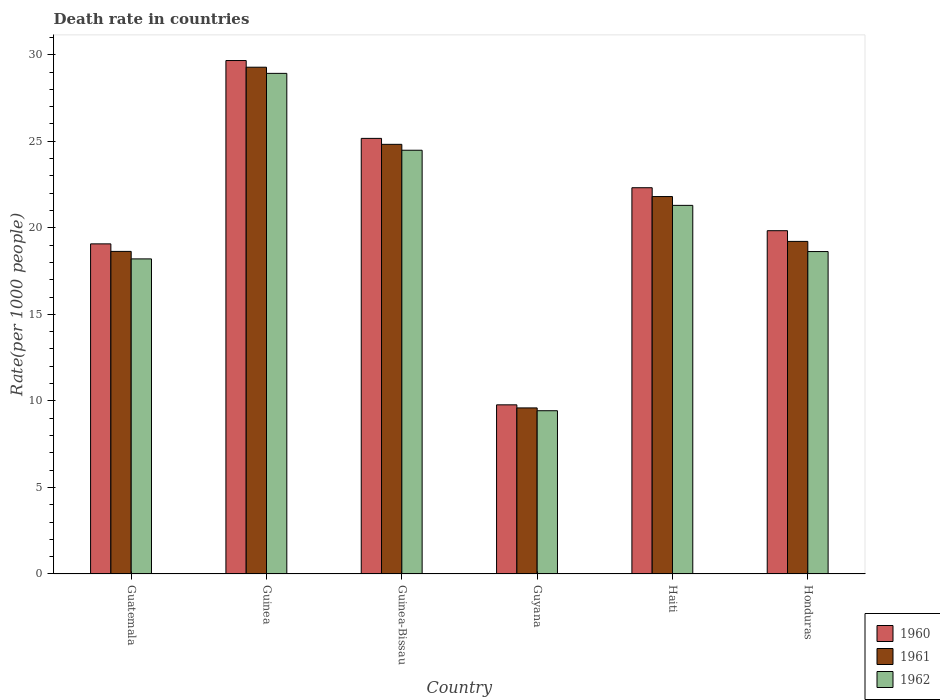Are the number of bars per tick equal to the number of legend labels?
Your answer should be compact. Yes. Are the number of bars on each tick of the X-axis equal?
Keep it short and to the point. Yes. How many bars are there on the 3rd tick from the left?
Make the answer very short. 3. How many bars are there on the 2nd tick from the right?
Make the answer very short. 3. What is the label of the 5th group of bars from the left?
Offer a terse response. Haiti. In how many cases, is the number of bars for a given country not equal to the number of legend labels?
Offer a very short reply. 0. What is the death rate in 1961 in Guatemala?
Offer a very short reply. 18.64. Across all countries, what is the maximum death rate in 1962?
Make the answer very short. 28.92. Across all countries, what is the minimum death rate in 1961?
Provide a short and direct response. 9.6. In which country was the death rate in 1962 maximum?
Your response must be concise. Guinea. In which country was the death rate in 1960 minimum?
Provide a succinct answer. Guyana. What is the total death rate in 1962 in the graph?
Provide a succinct answer. 120.97. What is the difference between the death rate in 1960 in Haiti and that in Honduras?
Offer a terse response. 2.48. What is the difference between the death rate in 1960 in Haiti and the death rate in 1961 in Guinea?
Your response must be concise. -6.96. What is the average death rate in 1962 per country?
Provide a short and direct response. 20.16. What is the difference between the death rate of/in 1962 and death rate of/in 1961 in Honduras?
Your answer should be compact. -0.59. What is the ratio of the death rate in 1960 in Guyana to that in Honduras?
Your answer should be compact. 0.49. Is the death rate in 1960 in Guinea-Bissau less than that in Haiti?
Provide a short and direct response. No. Is the difference between the death rate in 1962 in Guatemala and Haiti greater than the difference between the death rate in 1961 in Guatemala and Haiti?
Keep it short and to the point. Yes. What is the difference between the highest and the second highest death rate in 1961?
Give a very brief answer. 3.02. What is the difference between the highest and the lowest death rate in 1962?
Ensure brevity in your answer.  19.49. Is the sum of the death rate in 1962 in Guinea and Haiti greater than the maximum death rate in 1960 across all countries?
Ensure brevity in your answer.  Yes. What does the 1st bar from the left in Honduras represents?
Give a very brief answer. 1960. Is it the case that in every country, the sum of the death rate in 1961 and death rate in 1962 is greater than the death rate in 1960?
Your response must be concise. Yes. Are all the bars in the graph horizontal?
Your response must be concise. No. Are the values on the major ticks of Y-axis written in scientific E-notation?
Make the answer very short. No. Does the graph contain any zero values?
Ensure brevity in your answer.  No. Does the graph contain grids?
Offer a very short reply. No. What is the title of the graph?
Provide a succinct answer. Death rate in countries. What is the label or title of the Y-axis?
Make the answer very short. Rate(per 1000 people). What is the Rate(per 1000 people) in 1960 in Guatemala?
Your answer should be compact. 19.07. What is the Rate(per 1000 people) of 1961 in Guatemala?
Your answer should be compact. 18.64. What is the Rate(per 1000 people) in 1962 in Guatemala?
Your answer should be very brief. 18.2. What is the Rate(per 1000 people) in 1960 in Guinea?
Offer a very short reply. 29.66. What is the Rate(per 1000 people) of 1961 in Guinea?
Offer a terse response. 29.28. What is the Rate(per 1000 people) in 1962 in Guinea?
Offer a terse response. 28.92. What is the Rate(per 1000 people) of 1960 in Guinea-Bissau?
Your response must be concise. 25.17. What is the Rate(per 1000 people) in 1961 in Guinea-Bissau?
Ensure brevity in your answer.  24.82. What is the Rate(per 1000 people) in 1962 in Guinea-Bissau?
Ensure brevity in your answer.  24.48. What is the Rate(per 1000 people) of 1960 in Guyana?
Keep it short and to the point. 9.77. What is the Rate(per 1000 people) of 1961 in Guyana?
Provide a succinct answer. 9.6. What is the Rate(per 1000 people) in 1962 in Guyana?
Your answer should be compact. 9.43. What is the Rate(per 1000 people) in 1960 in Haiti?
Keep it short and to the point. 22.32. What is the Rate(per 1000 people) in 1961 in Haiti?
Ensure brevity in your answer.  21.81. What is the Rate(per 1000 people) in 1962 in Haiti?
Keep it short and to the point. 21.3. What is the Rate(per 1000 people) in 1960 in Honduras?
Provide a short and direct response. 19.83. What is the Rate(per 1000 people) in 1961 in Honduras?
Offer a very short reply. 19.22. What is the Rate(per 1000 people) in 1962 in Honduras?
Ensure brevity in your answer.  18.63. Across all countries, what is the maximum Rate(per 1000 people) in 1960?
Give a very brief answer. 29.66. Across all countries, what is the maximum Rate(per 1000 people) of 1961?
Your answer should be compact. 29.28. Across all countries, what is the maximum Rate(per 1000 people) of 1962?
Make the answer very short. 28.92. Across all countries, what is the minimum Rate(per 1000 people) of 1960?
Offer a terse response. 9.77. Across all countries, what is the minimum Rate(per 1000 people) in 1961?
Your response must be concise. 9.6. Across all countries, what is the minimum Rate(per 1000 people) of 1962?
Your answer should be compact. 9.43. What is the total Rate(per 1000 people) of 1960 in the graph?
Keep it short and to the point. 125.83. What is the total Rate(per 1000 people) of 1961 in the graph?
Give a very brief answer. 123.36. What is the total Rate(per 1000 people) of 1962 in the graph?
Offer a terse response. 120.97. What is the difference between the Rate(per 1000 people) in 1960 in Guatemala and that in Guinea?
Offer a very short reply. -10.59. What is the difference between the Rate(per 1000 people) of 1961 in Guatemala and that in Guinea?
Make the answer very short. -10.64. What is the difference between the Rate(per 1000 people) in 1962 in Guatemala and that in Guinea?
Make the answer very short. -10.72. What is the difference between the Rate(per 1000 people) in 1960 in Guatemala and that in Guinea-Bissau?
Your answer should be very brief. -6.09. What is the difference between the Rate(per 1000 people) in 1961 in Guatemala and that in Guinea-Bissau?
Provide a short and direct response. -6.19. What is the difference between the Rate(per 1000 people) in 1962 in Guatemala and that in Guinea-Bissau?
Give a very brief answer. -6.28. What is the difference between the Rate(per 1000 people) of 1961 in Guatemala and that in Guyana?
Your answer should be compact. 9.04. What is the difference between the Rate(per 1000 people) in 1962 in Guatemala and that in Guyana?
Ensure brevity in your answer.  8.77. What is the difference between the Rate(per 1000 people) in 1960 in Guatemala and that in Haiti?
Keep it short and to the point. -3.24. What is the difference between the Rate(per 1000 people) of 1961 in Guatemala and that in Haiti?
Give a very brief answer. -3.17. What is the difference between the Rate(per 1000 people) in 1962 in Guatemala and that in Haiti?
Your response must be concise. -3.09. What is the difference between the Rate(per 1000 people) in 1960 in Guatemala and that in Honduras?
Provide a succinct answer. -0.76. What is the difference between the Rate(per 1000 people) in 1961 in Guatemala and that in Honduras?
Your answer should be very brief. -0.58. What is the difference between the Rate(per 1000 people) of 1962 in Guatemala and that in Honduras?
Your answer should be compact. -0.42. What is the difference between the Rate(per 1000 people) in 1960 in Guinea and that in Guinea-Bissau?
Offer a very short reply. 4.5. What is the difference between the Rate(per 1000 people) in 1961 in Guinea and that in Guinea-Bissau?
Offer a very short reply. 4.46. What is the difference between the Rate(per 1000 people) in 1962 in Guinea and that in Guinea-Bissau?
Your answer should be very brief. 4.44. What is the difference between the Rate(per 1000 people) of 1960 in Guinea and that in Guyana?
Offer a terse response. 19.89. What is the difference between the Rate(per 1000 people) in 1961 in Guinea and that in Guyana?
Offer a very short reply. 19.68. What is the difference between the Rate(per 1000 people) in 1962 in Guinea and that in Guyana?
Make the answer very short. 19.49. What is the difference between the Rate(per 1000 people) in 1960 in Guinea and that in Haiti?
Your answer should be very brief. 7.35. What is the difference between the Rate(per 1000 people) of 1961 in Guinea and that in Haiti?
Offer a very short reply. 7.47. What is the difference between the Rate(per 1000 people) of 1962 in Guinea and that in Haiti?
Make the answer very short. 7.63. What is the difference between the Rate(per 1000 people) in 1960 in Guinea and that in Honduras?
Keep it short and to the point. 9.83. What is the difference between the Rate(per 1000 people) in 1961 in Guinea and that in Honduras?
Offer a very short reply. 10.06. What is the difference between the Rate(per 1000 people) of 1962 in Guinea and that in Honduras?
Keep it short and to the point. 10.29. What is the difference between the Rate(per 1000 people) in 1960 in Guinea-Bissau and that in Guyana?
Your response must be concise. 15.39. What is the difference between the Rate(per 1000 people) of 1961 in Guinea-Bissau and that in Guyana?
Offer a terse response. 15.23. What is the difference between the Rate(per 1000 people) in 1962 in Guinea-Bissau and that in Guyana?
Give a very brief answer. 15.05. What is the difference between the Rate(per 1000 people) in 1960 in Guinea-Bissau and that in Haiti?
Give a very brief answer. 2.85. What is the difference between the Rate(per 1000 people) in 1961 in Guinea-Bissau and that in Haiti?
Make the answer very short. 3.02. What is the difference between the Rate(per 1000 people) in 1962 in Guinea-Bissau and that in Haiti?
Your answer should be very brief. 3.19. What is the difference between the Rate(per 1000 people) of 1960 in Guinea-Bissau and that in Honduras?
Your answer should be very brief. 5.33. What is the difference between the Rate(per 1000 people) in 1961 in Guinea-Bissau and that in Honduras?
Make the answer very short. 5.61. What is the difference between the Rate(per 1000 people) in 1962 in Guinea-Bissau and that in Honduras?
Your response must be concise. 5.85. What is the difference between the Rate(per 1000 people) of 1960 in Guyana and that in Haiti?
Your answer should be very brief. -12.54. What is the difference between the Rate(per 1000 people) of 1961 in Guyana and that in Haiti?
Offer a very short reply. -12.21. What is the difference between the Rate(per 1000 people) in 1962 in Guyana and that in Haiti?
Offer a very short reply. -11.87. What is the difference between the Rate(per 1000 people) in 1960 in Guyana and that in Honduras?
Ensure brevity in your answer.  -10.06. What is the difference between the Rate(per 1000 people) in 1961 in Guyana and that in Honduras?
Your answer should be very brief. -9.62. What is the difference between the Rate(per 1000 people) in 1962 in Guyana and that in Honduras?
Your response must be concise. -9.2. What is the difference between the Rate(per 1000 people) of 1960 in Haiti and that in Honduras?
Provide a short and direct response. 2.48. What is the difference between the Rate(per 1000 people) of 1961 in Haiti and that in Honduras?
Your response must be concise. 2.59. What is the difference between the Rate(per 1000 people) of 1962 in Haiti and that in Honduras?
Ensure brevity in your answer.  2.67. What is the difference between the Rate(per 1000 people) of 1960 in Guatemala and the Rate(per 1000 people) of 1961 in Guinea?
Give a very brief answer. -10.21. What is the difference between the Rate(per 1000 people) of 1960 in Guatemala and the Rate(per 1000 people) of 1962 in Guinea?
Provide a succinct answer. -9.85. What is the difference between the Rate(per 1000 people) in 1961 in Guatemala and the Rate(per 1000 people) in 1962 in Guinea?
Offer a very short reply. -10.29. What is the difference between the Rate(per 1000 people) in 1960 in Guatemala and the Rate(per 1000 people) in 1961 in Guinea-Bissau?
Your response must be concise. -5.75. What is the difference between the Rate(per 1000 people) in 1960 in Guatemala and the Rate(per 1000 people) in 1962 in Guinea-Bissau?
Offer a terse response. -5.41. What is the difference between the Rate(per 1000 people) in 1961 in Guatemala and the Rate(per 1000 people) in 1962 in Guinea-Bissau?
Give a very brief answer. -5.84. What is the difference between the Rate(per 1000 people) of 1960 in Guatemala and the Rate(per 1000 people) of 1961 in Guyana?
Your answer should be compact. 9.48. What is the difference between the Rate(per 1000 people) in 1960 in Guatemala and the Rate(per 1000 people) in 1962 in Guyana?
Provide a short and direct response. 9.64. What is the difference between the Rate(per 1000 people) of 1961 in Guatemala and the Rate(per 1000 people) of 1962 in Guyana?
Provide a short and direct response. 9.21. What is the difference between the Rate(per 1000 people) of 1960 in Guatemala and the Rate(per 1000 people) of 1961 in Haiti?
Your answer should be very brief. -2.73. What is the difference between the Rate(per 1000 people) of 1960 in Guatemala and the Rate(per 1000 people) of 1962 in Haiti?
Offer a very short reply. -2.23. What is the difference between the Rate(per 1000 people) of 1961 in Guatemala and the Rate(per 1000 people) of 1962 in Haiti?
Offer a terse response. -2.66. What is the difference between the Rate(per 1000 people) in 1960 in Guatemala and the Rate(per 1000 people) in 1961 in Honduras?
Provide a succinct answer. -0.14. What is the difference between the Rate(per 1000 people) of 1960 in Guatemala and the Rate(per 1000 people) of 1962 in Honduras?
Provide a short and direct response. 0.44. What is the difference between the Rate(per 1000 people) in 1961 in Guatemala and the Rate(per 1000 people) in 1962 in Honduras?
Your answer should be very brief. 0.01. What is the difference between the Rate(per 1000 people) in 1960 in Guinea and the Rate(per 1000 people) in 1961 in Guinea-Bissau?
Give a very brief answer. 4.84. What is the difference between the Rate(per 1000 people) of 1960 in Guinea and the Rate(per 1000 people) of 1962 in Guinea-Bissau?
Provide a short and direct response. 5.18. What is the difference between the Rate(per 1000 people) of 1961 in Guinea and the Rate(per 1000 people) of 1962 in Guinea-Bissau?
Your answer should be compact. 4.8. What is the difference between the Rate(per 1000 people) in 1960 in Guinea and the Rate(per 1000 people) in 1961 in Guyana?
Your response must be concise. 20.07. What is the difference between the Rate(per 1000 people) of 1960 in Guinea and the Rate(per 1000 people) of 1962 in Guyana?
Provide a succinct answer. 20.23. What is the difference between the Rate(per 1000 people) of 1961 in Guinea and the Rate(per 1000 people) of 1962 in Guyana?
Ensure brevity in your answer.  19.85. What is the difference between the Rate(per 1000 people) of 1960 in Guinea and the Rate(per 1000 people) of 1961 in Haiti?
Your answer should be very brief. 7.86. What is the difference between the Rate(per 1000 people) of 1960 in Guinea and the Rate(per 1000 people) of 1962 in Haiti?
Make the answer very short. 8.37. What is the difference between the Rate(per 1000 people) in 1961 in Guinea and the Rate(per 1000 people) in 1962 in Haiti?
Your answer should be compact. 7.98. What is the difference between the Rate(per 1000 people) in 1960 in Guinea and the Rate(per 1000 people) in 1961 in Honduras?
Offer a terse response. 10.45. What is the difference between the Rate(per 1000 people) in 1960 in Guinea and the Rate(per 1000 people) in 1962 in Honduras?
Your response must be concise. 11.04. What is the difference between the Rate(per 1000 people) of 1961 in Guinea and the Rate(per 1000 people) of 1962 in Honduras?
Provide a short and direct response. 10.65. What is the difference between the Rate(per 1000 people) in 1960 in Guinea-Bissau and the Rate(per 1000 people) in 1961 in Guyana?
Give a very brief answer. 15.57. What is the difference between the Rate(per 1000 people) of 1960 in Guinea-Bissau and the Rate(per 1000 people) of 1962 in Guyana?
Your response must be concise. 15.74. What is the difference between the Rate(per 1000 people) in 1961 in Guinea-Bissau and the Rate(per 1000 people) in 1962 in Guyana?
Your response must be concise. 15.39. What is the difference between the Rate(per 1000 people) in 1960 in Guinea-Bissau and the Rate(per 1000 people) in 1961 in Haiti?
Offer a terse response. 3.36. What is the difference between the Rate(per 1000 people) of 1960 in Guinea-Bissau and the Rate(per 1000 people) of 1962 in Haiti?
Provide a short and direct response. 3.87. What is the difference between the Rate(per 1000 people) of 1961 in Guinea-Bissau and the Rate(per 1000 people) of 1962 in Haiti?
Ensure brevity in your answer.  3.53. What is the difference between the Rate(per 1000 people) of 1960 in Guinea-Bissau and the Rate(per 1000 people) of 1961 in Honduras?
Your answer should be compact. 5.95. What is the difference between the Rate(per 1000 people) in 1960 in Guinea-Bissau and the Rate(per 1000 people) in 1962 in Honduras?
Ensure brevity in your answer.  6.54. What is the difference between the Rate(per 1000 people) in 1961 in Guinea-Bissau and the Rate(per 1000 people) in 1962 in Honduras?
Keep it short and to the point. 6.2. What is the difference between the Rate(per 1000 people) of 1960 in Guyana and the Rate(per 1000 people) of 1961 in Haiti?
Your response must be concise. -12.03. What is the difference between the Rate(per 1000 people) of 1960 in Guyana and the Rate(per 1000 people) of 1962 in Haiti?
Offer a very short reply. -11.53. What is the difference between the Rate(per 1000 people) of 1961 in Guyana and the Rate(per 1000 people) of 1962 in Haiti?
Offer a terse response. -11.7. What is the difference between the Rate(per 1000 people) of 1960 in Guyana and the Rate(per 1000 people) of 1961 in Honduras?
Your response must be concise. -9.44. What is the difference between the Rate(per 1000 people) in 1960 in Guyana and the Rate(per 1000 people) in 1962 in Honduras?
Ensure brevity in your answer.  -8.86. What is the difference between the Rate(per 1000 people) in 1961 in Guyana and the Rate(per 1000 people) in 1962 in Honduras?
Provide a succinct answer. -9.03. What is the difference between the Rate(per 1000 people) of 1960 in Haiti and the Rate(per 1000 people) of 1961 in Honduras?
Offer a terse response. 3.1. What is the difference between the Rate(per 1000 people) of 1960 in Haiti and the Rate(per 1000 people) of 1962 in Honduras?
Your answer should be very brief. 3.69. What is the difference between the Rate(per 1000 people) in 1961 in Haiti and the Rate(per 1000 people) in 1962 in Honduras?
Your response must be concise. 3.18. What is the average Rate(per 1000 people) in 1960 per country?
Your response must be concise. 20.97. What is the average Rate(per 1000 people) in 1961 per country?
Keep it short and to the point. 20.56. What is the average Rate(per 1000 people) of 1962 per country?
Provide a short and direct response. 20.16. What is the difference between the Rate(per 1000 people) of 1960 and Rate(per 1000 people) of 1961 in Guatemala?
Your answer should be very brief. 0.43. What is the difference between the Rate(per 1000 people) of 1960 and Rate(per 1000 people) of 1962 in Guatemala?
Your answer should be very brief. 0.87. What is the difference between the Rate(per 1000 people) of 1961 and Rate(per 1000 people) of 1962 in Guatemala?
Keep it short and to the point. 0.43. What is the difference between the Rate(per 1000 people) of 1960 and Rate(per 1000 people) of 1961 in Guinea?
Keep it short and to the point. 0.39. What is the difference between the Rate(per 1000 people) of 1960 and Rate(per 1000 people) of 1962 in Guinea?
Your answer should be very brief. 0.74. What is the difference between the Rate(per 1000 people) of 1961 and Rate(per 1000 people) of 1962 in Guinea?
Your answer should be compact. 0.36. What is the difference between the Rate(per 1000 people) in 1960 and Rate(per 1000 people) in 1961 in Guinea-Bissau?
Your answer should be compact. 0.34. What is the difference between the Rate(per 1000 people) in 1960 and Rate(per 1000 people) in 1962 in Guinea-Bissau?
Your answer should be very brief. 0.69. What is the difference between the Rate(per 1000 people) of 1961 and Rate(per 1000 people) of 1962 in Guinea-Bissau?
Make the answer very short. 0.34. What is the difference between the Rate(per 1000 people) in 1960 and Rate(per 1000 people) in 1961 in Guyana?
Your answer should be very brief. 0.18. What is the difference between the Rate(per 1000 people) of 1960 and Rate(per 1000 people) of 1962 in Guyana?
Give a very brief answer. 0.34. What is the difference between the Rate(per 1000 people) in 1961 and Rate(per 1000 people) in 1962 in Guyana?
Offer a very short reply. 0.16. What is the difference between the Rate(per 1000 people) of 1960 and Rate(per 1000 people) of 1961 in Haiti?
Provide a succinct answer. 0.51. What is the difference between the Rate(per 1000 people) of 1960 and Rate(per 1000 people) of 1962 in Haiti?
Ensure brevity in your answer.  1.02. What is the difference between the Rate(per 1000 people) of 1961 and Rate(per 1000 people) of 1962 in Haiti?
Your answer should be compact. 0.51. What is the difference between the Rate(per 1000 people) of 1960 and Rate(per 1000 people) of 1961 in Honduras?
Give a very brief answer. 0.62. What is the difference between the Rate(per 1000 people) of 1960 and Rate(per 1000 people) of 1962 in Honduras?
Your answer should be very brief. 1.21. What is the difference between the Rate(per 1000 people) of 1961 and Rate(per 1000 people) of 1962 in Honduras?
Your answer should be very brief. 0.59. What is the ratio of the Rate(per 1000 people) of 1960 in Guatemala to that in Guinea?
Offer a very short reply. 0.64. What is the ratio of the Rate(per 1000 people) of 1961 in Guatemala to that in Guinea?
Offer a very short reply. 0.64. What is the ratio of the Rate(per 1000 people) in 1962 in Guatemala to that in Guinea?
Offer a very short reply. 0.63. What is the ratio of the Rate(per 1000 people) of 1960 in Guatemala to that in Guinea-Bissau?
Provide a short and direct response. 0.76. What is the ratio of the Rate(per 1000 people) of 1961 in Guatemala to that in Guinea-Bissau?
Provide a succinct answer. 0.75. What is the ratio of the Rate(per 1000 people) in 1962 in Guatemala to that in Guinea-Bissau?
Offer a very short reply. 0.74. What is the ratio of the Rate(per 1000 people) in 1960 in Guatemala to that in Guyana?
Provide a short and direct response. 1.95. What is the ratio of the Rate(per 1000 people) of 1961 in Guatemala to that in Guyana?
Keep it short and to the point. 1.94. What is the ratio of the Rate(per 1000 people) in 1962 in Guatemala to that in Guyana?
Provide a short and direct response. 1.93. What is the ratio of the Rate(per 1000 people) in 1960 in Guatemala to that in Haiti?
Your answer should be very brief. 0.85. What is the ratio of the Rate(per 1000 people) of 1961 in Guatemala to that in Haiti?
Your answer should be very brief. 0.85. What is the ratio of the Rate(per 1000 people) in 1962 in Guatemala to that in Haiti?
Offer a very short reply. 0.85. What is the ratio of the Rate(per 1000 people) of 1960 in Guatemala to that in Honduras?
Provide a short and direct response. 0.96. What is the ratio of the Rate(per 1000 people) in 1961 in Guatemala to that in Honduras?
Offer a very short reply. 0.97. What is the ratio of the Rate(per 1000 people) in 1962 in Guatemala to that in Honduras?
Keep it short and to the point. 0.98. What is the ratio of the Rate(per 1000 people) of 1960 in Guinea to that in Guinea-Bissau?
Offer a very short reply. 1.18. What is the ratio of the Rate(per 1000 people) in 1961 in Guinea to that in Guinea-Bissau?
Make the answer very short. 1.18. What is the ratio of the Rate(per 1000 people) in 1962 in Guinea to that in Guinea-Bissau?
Make the answer very short. 1.18. What is the ratio of the Rate(per 1000 people) of 1960 in Guinea to that in Guyana?
Your response must be concise. 3.04. What is the ratio of the Rate(per 1000 people) in 1961 in Guinea to that in Guyana?
Your response must be concise. 3.05. What is the ratio of the Rate(per 1000 people) in 1962 in Guinea to that in Guyana?
Provide a short and direct response. 3.07. What is the ratio of the Rate(per 1000 people) of 1960 in Guinea to that in Haiti?
Ensure brevity in your answer.  1.33. What is the ratio of the Rate(per 1000 people) in 1961 in Guinea to that in Haiti?
Provide a succinct answer. 1.34. What is the ratio of the Rate(per 1000 people) of 1962 in Guinea to that in Haiti?
Provide a succinct answer. 1.36. What is the ratio of the Rate(per 1000 people) in 1960 in Guinea to that in Honduras?
Offer a very short reply. 1.5. What is the ratio of the Rate(per 1000 people) in 1961 in Guinea to that in Honduras?
Your answer should be compact. 1.52. What is the ratio of the Rate(per 1000 people) of 1962 in Guinea to that in Honduras?
Offer a very short reply. 1.55. What is the ratio of the Rate(per 1000 people) in 1960 in Guinea-Bissau to that in Guyana?
Give a very brief answer. 2.58. What is the ratio of the Rate(per 1000 people) of 1961 in Guinea-Bissau to that in Guyana?
Your answer should be compact. 2.59. What is the ratio of the Rate(per 1000 people) of 1962 in Guinea-Bissau to that in Guyana?
Your answer should be compact. 2.6. What is the ratio of the Rate(per 1000 people) of 1960 in Guinea-Bissau to that in Haiti?
Give a very brief answer. 1.13. What is the ratio of the Rate(per 1000 people) in 1961 in Guinea-Bissau to that in Haiti?
Your answer should be compact. 1.14. What is the ratio of the Rate(per 1000 people) in 1962 in Guinea-Bissau to that in Haiti?
Ensure brevity in your answer.  1.15. What is the ratio of the Rate(per 1000 people) of 1960 in Guinea-Bissau to that in Honduras?
Your answer should be compact. 1.27. What is the ratio of the Rate(per 1000 people) in 1961 in Guinea-Bissau to that in Honduras?
Your response must be concise. 1.29. What is the ratio of the Rate(per 1000 people) in 1962 in Guinea-Bissau to that in Honduras?
Give a very brief answer. 1.31. What is the ratio of the Rate(per 1000 people) of 1960 in Guyana to that in Haiti?
Give a very brief answer. 0.44. What is the ratio of the Rate(per 1000 people) in 1961 in Guyana to that in Haiti?
Your response must be concise. 0.44. What is the ratio of the Rate(per 1000 people) of 1962 in Guyana to that in Haiti?
Offer a very short reply. 0.44. What is the ratio of the Rate(per 1000 people) of 1960 in Guyana to that in Honduras?
Your answer should be compact. 0.49. What is the ratio of the Rate(per 1000 people) in 1961 in Guyana to that in Honduras?
Your answer should be compact. 0.5. What is the ratio of the Rate(per 1000 people) of 1962 in Guyana to that in Honduras?
Ensure brevity in your answer.  0.51. What is the ratio of the Rate(per 1000 people) of 1960 in Haiti to that in Honduras?
Your answer should be very brief. 1.13. What is the ratio of the Rate(per 1000 people) of 1961 in Haiti to that in Honduras?
Provide a short and direct response. 1.13. What is the ratio of the Rate(per 1000 people) in 1962 in Haiti to that in Honduras?
Make the answer very short. 1.14. What is the difference between the highest and the second highest Rate(per 1000 people) of 1960?
Ensure brevity in your answer.  4.5. What is the difference between the highest and the second highest Rate(per 1000 people) of 1961?
Offer a very short reply. 4.46. What is the difference between the highest and the second highest Rate(per 1000 people) in 1962?
Offer a very short reply. 4.44. What is the difference between the highest and the lowest Rate(per 1000 people) of 1960?
Make the answer very short. 19.89. What is the difference between the highest and the lowest Rate(per 1000 people) of 1961?
Ensure brevity in your answer.  19.68. What is the difference between the highest and the lowest Rate(per 1000 people) in 1962?
Ensure brevity in your answer.  19.49. 